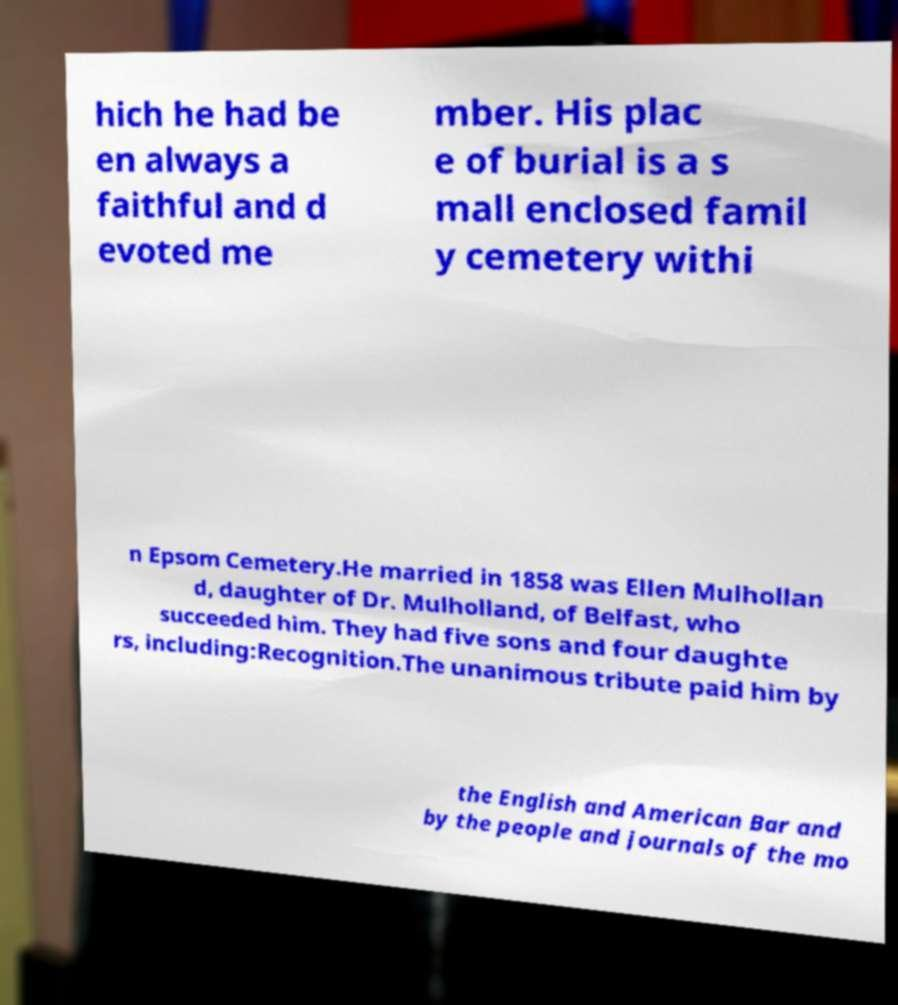For documentation purposes, I need the text within this image transcribed. Could you provide that? hich he had be en always a faithful and d evoted me mber. His plac e of burial is a s mall enclosed famil y cemetery withi n Epsom Cemetery.He married in 1858 was Ellen Mulhollan d, daughter of Dr. Mulholland, of Belfast, who succeeded him. They had five sons and four daughte rs, including:Recognition.The unanimous tribute paid him by the English and American Bar and by the people and journals of the mo 